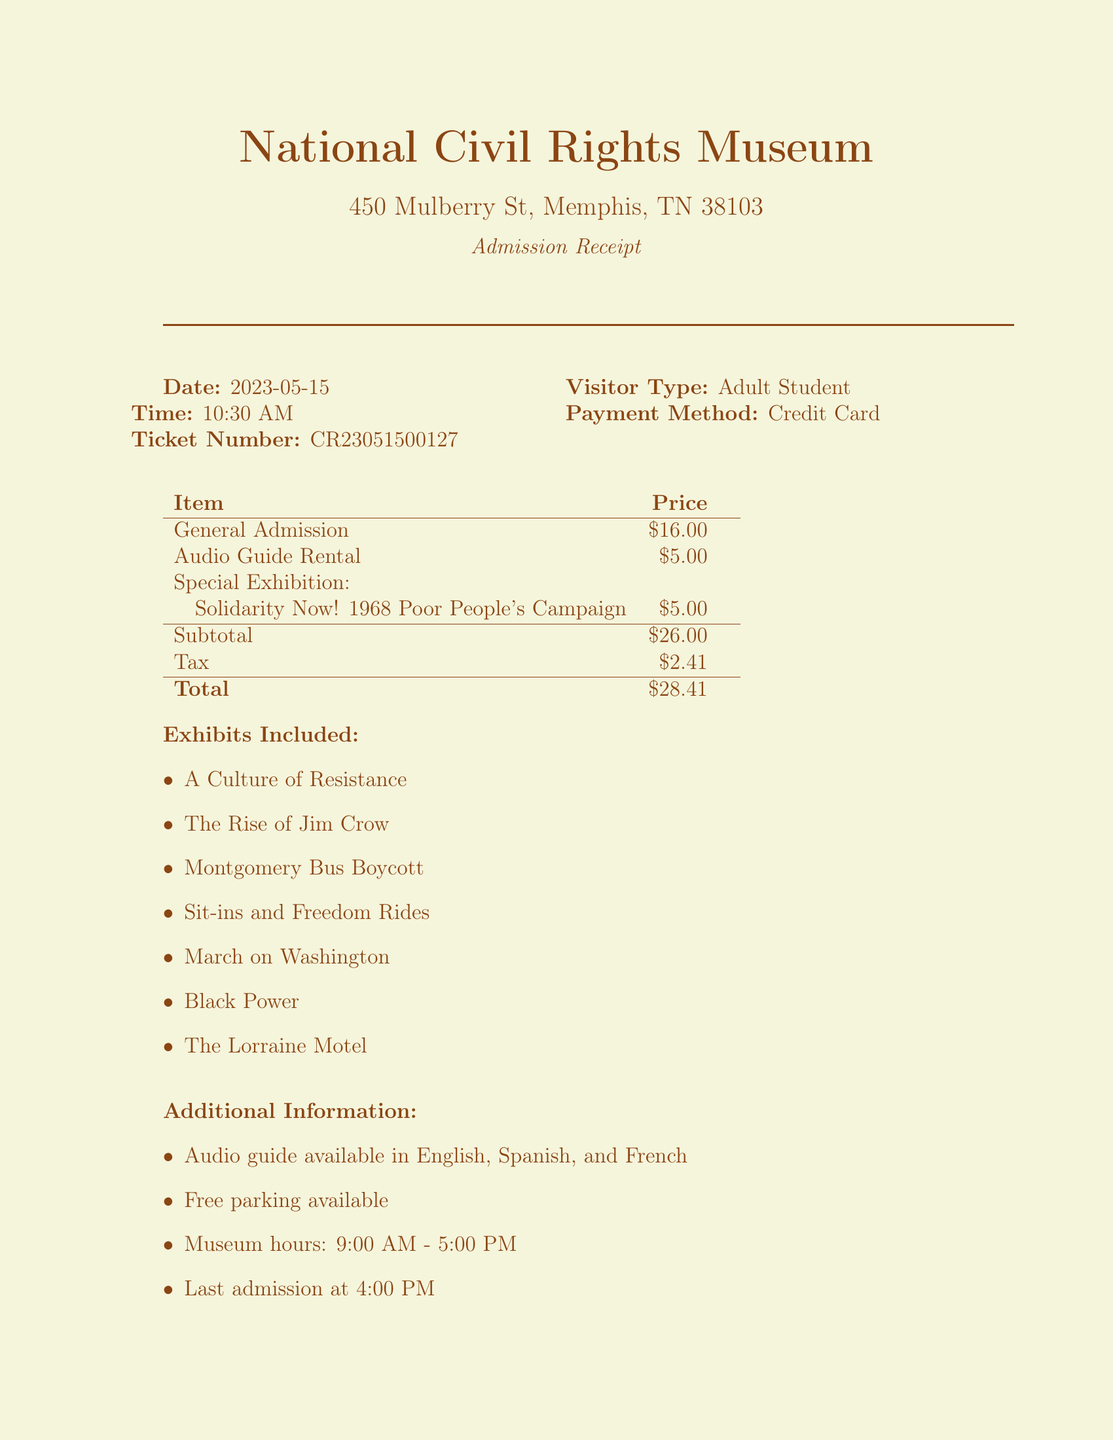What is the name of the museum? The name of the museum is specified in the document as the National Civil Rights Museum.
Answer: National Civil Rights Museum What is the total cost for admission? The total cost for admission is provided in the document, including tax and fees.
Answer: $28.41 On what date was the ticket purchased? The purchase date of the ticket is clearly mentioned in the document.
Answer: 2023-05-15 What visitor type was specified on the receipt? The document states the visitor type which indicates the category of the ticket buyer.
Answer: Adult Student How much does the audio guide rental cost? The cost for the audio guide rental is listed in the item breakdown.
Answer: $5.00 What is the fee for the special exhibition? The specific fee for the mentioned special exhibition is included in the document.
Answer: $5.00 What exhibits are included in the admission? The document lists various exhibits included in the admission for visitors.
Answer: A Culture of Resistance, The Rise of Jim Crow, Montgomery Bus Boycott, Sit-ins and Freedom Rides, March on Washington, Black Power, The Lorraine Motel Which payment method was used? The payment method for the transaction is indicated in the document.
Answer: Credit Card What educational resource is available at the Information Desk? The document specifies a type of educational resource that can be found at the Information Desk.
Answer: Student Study Guide 